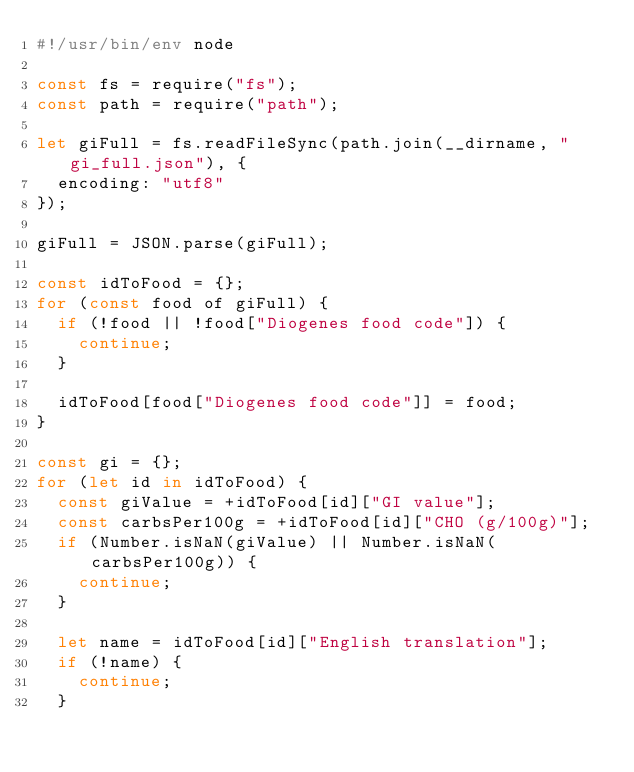Convert code to text. <code><loc_0><loc_0><loc_500><loc_500><_JavaScript_>#!/usr/bin/env node

const fs = require("fs");
const path = require("path");

let giFull = fs.readFileSync(path.join(__dirname, "gi_full.json"), {
  encoding: "utf8"
});

giFull = JSON.parse(giFull);

const idToFood = {};
for (const food of giFull) {
  if (!food || !food["Diogenes food code"]) {
    continue;
  }

  idToFood[food["Diogenes food code"]] = food;
}

const gi = {};
for (let id in idToFood) {
  const giValue = +idToFood[id]["GI value"];
  const carbsPer100g = +idToFood[id]["CHO (g/100g)"];
  if (Number.isNaN(giValue) || Number.isNaN(carbsPer100g)) {
    continue;
  }

  let name = idToFood[id]["English translation"];
  if (!name) {
    continue;
  }</code> 